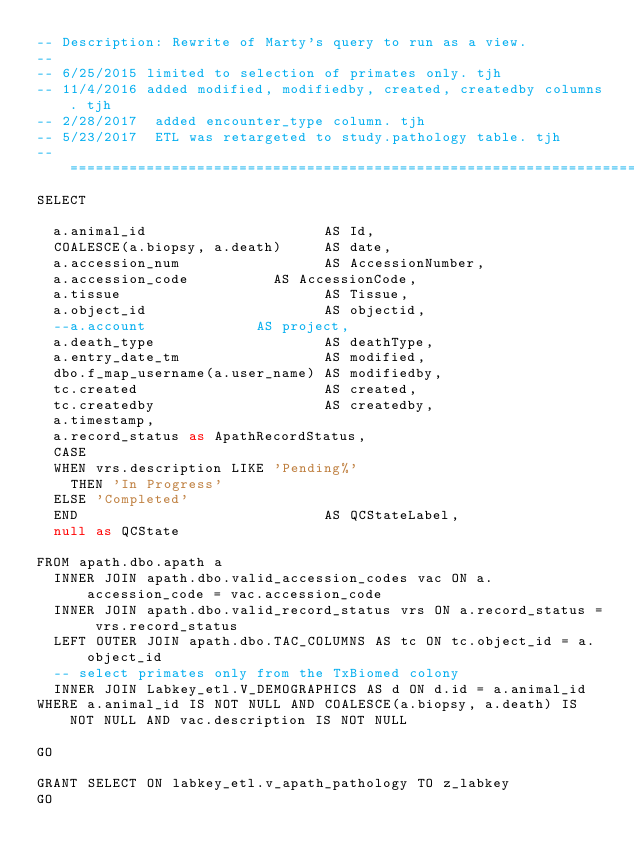<code> <loc_0><loc_0><loc_500><loc_500><_SQL_>-- Description:	Rewrite of Marty's query to run as a view.
--
-- 6/25/2015 limited to selection of primates only. tjh
-- 11/4/2016 added modified, modifiedby, created, createdby columns. tjh
-- 2/28/2017	added encounter_type column. tjh
-- 5/23/2017	ETL was retargeted to study.pathology table. tjh
-- ==========================================================================================
SELECT

  a.animal_id                     AS Id,
  COALESCE(a.biopsy, a.death)     AS date,
  a.accession_num                 AS AccessionNumber,
  a.accession_code				  AS AccessionCode,
  a.tissue                        AS Tissue,
  a.object_id                     AS objectid,
  --a.account						  AS project,
  a.death_type                    AS deathType,
  a.entry_date_tm                 AS modified,
  dbo.f_map_username(a.user_name) AS modifiedby,
  tc.created                      AS created,
  tc.createdby                    AS createdby,
  a.timestamp,
  a.record_status as ApathRecordStatus,
  CASE
  WHEN vrs.description LIKE 'Pending%'
    THEN 'In Progress'
  ELSE 'Completed'
  END                             AS QCStateLabel,
  null as QCState

FROM apath.dbo.apath a
  INNER JOIN apath.dbo.valid_accession_codes vac ON a.accession_code = vac.accession_code
  INNER JOIN apath.dbo.valid_record_status vrs ON a.record_status = vrs.record_status
  LEFT OUTER JOIN apath.dbo.TAC_COLUMNS AS tc ON tc.object_id = a.object_id
  -- select primates only from the TxBiomed colony
  INNER JOIN Labkey_etl.V_DEMOGRAPHICS AS d ON d.id = a.animal_id
WHERE a.animal_id IS NOT NULL AND COALESCE(a.biopsy, a.death) IS NOT NULL AND vac.description IS NOT NULL

GO

GRANT SELECT ON labkey_etl.v_apath_pathology TO z_labkey
GO</code> 